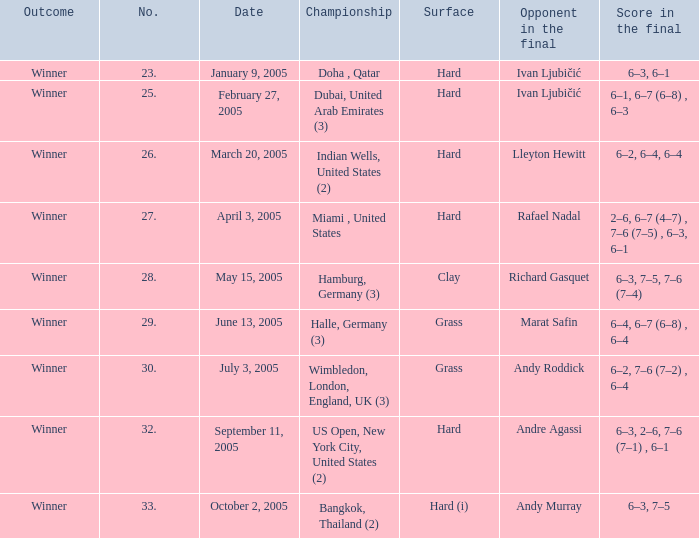In the miami championship taking place in the united states, what's the score during the final match? 2–6, 6–7 (4–7) , 7–6 (7–5) , 6–3, 6–1. 